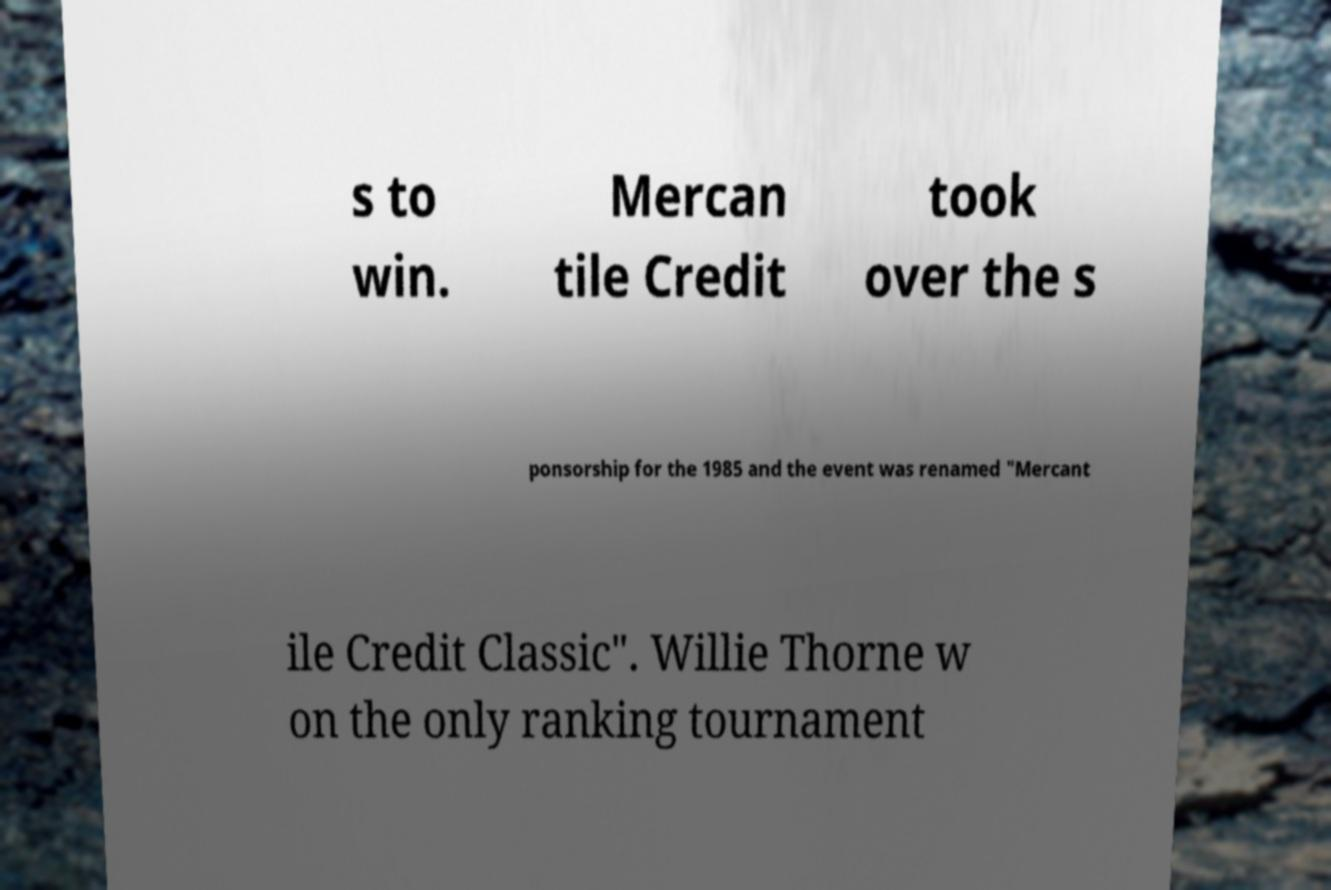For documentation purposes, I need the text within this image transcribed. Could you provide that? s to win. Mercan tile Credit took over the s ponsorship for the 1985 and the event was renamed "Mercant ile Credit Classic". Willie Thorne w on the only ranking tournament 